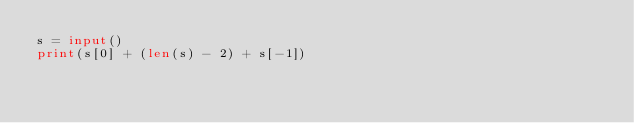Convert code to text. <code><loc_0><loc_0><loc_500><loc_500><_Python_>s = input()
print(s[0] + (len(s) - 2) + s[-1])</code> 